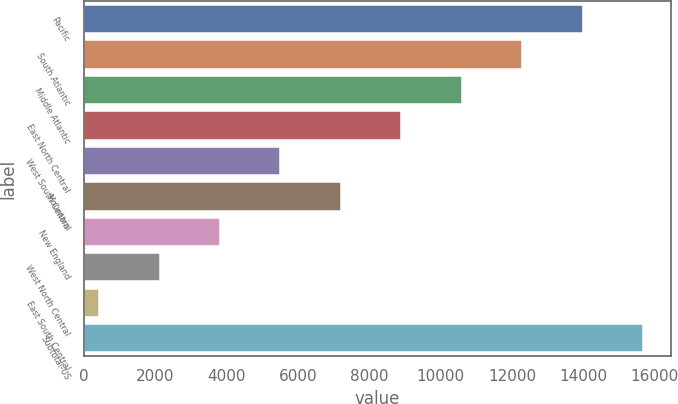Convert chart. <chart><loc_0><loc_0><loc_500><loc_500><bar_chart><fcel>Pacific<fcel>South Atlantic<fcel>Middle Atlantic<fcel>East North Central<fcel>West South Central<fcel>Mountain<fcel>New England<fcel>West North Central<fcel>East South Central<fcel>Subtotal-US<nl><fcel>13978.4<fcel>12283.1<fcel>10587.8<fcel>8892.5<fcel>5501.9<fcel>7197.2<fcel>3806.6<fcel>2111.3<fcel>416<fcel>15673.7<nl></chart> 